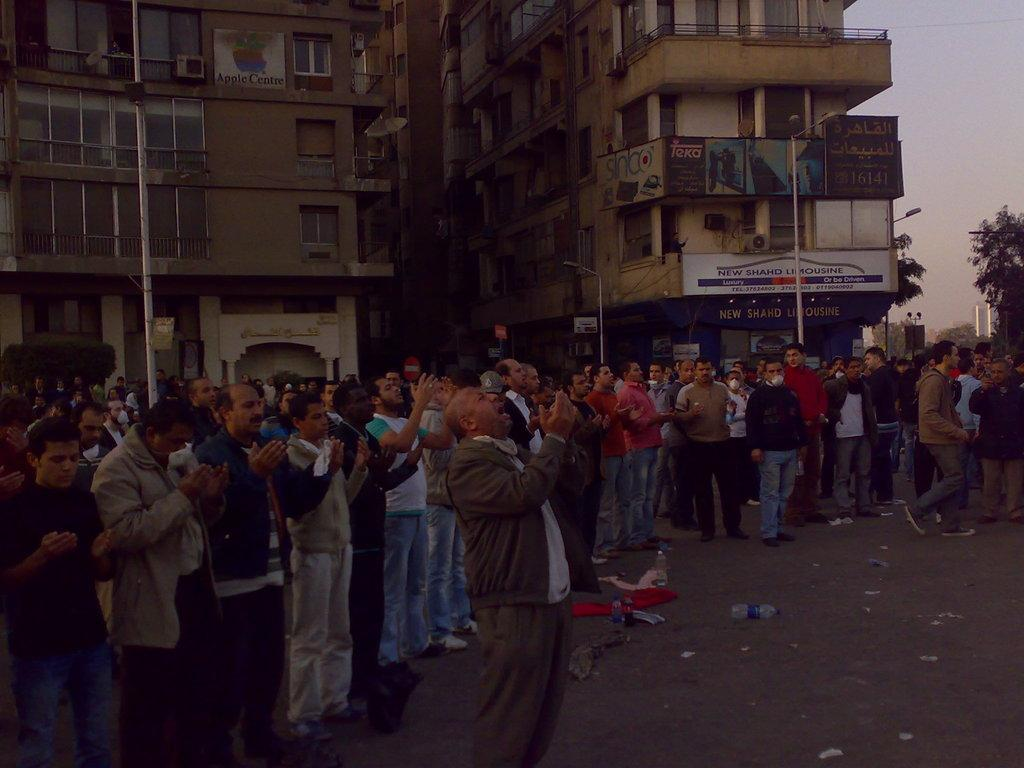What are the people in the image doing? The group of people is standing on the road. What objects can be seen on the road? Bottles are visible in the image. What structures are present along the road? Poles and buildings with windows are present in the image. What additional decorations or signs are visible? Banners are in the image. What type of natural elements can be seen in the image? Trees are visible in the image. What is visible in the background of the image? The sky is visible in the background of the image. What type of nest can be seen in the image? There is no nest present in the image. Is the queen visible in the image? There is no queen present in the image. 